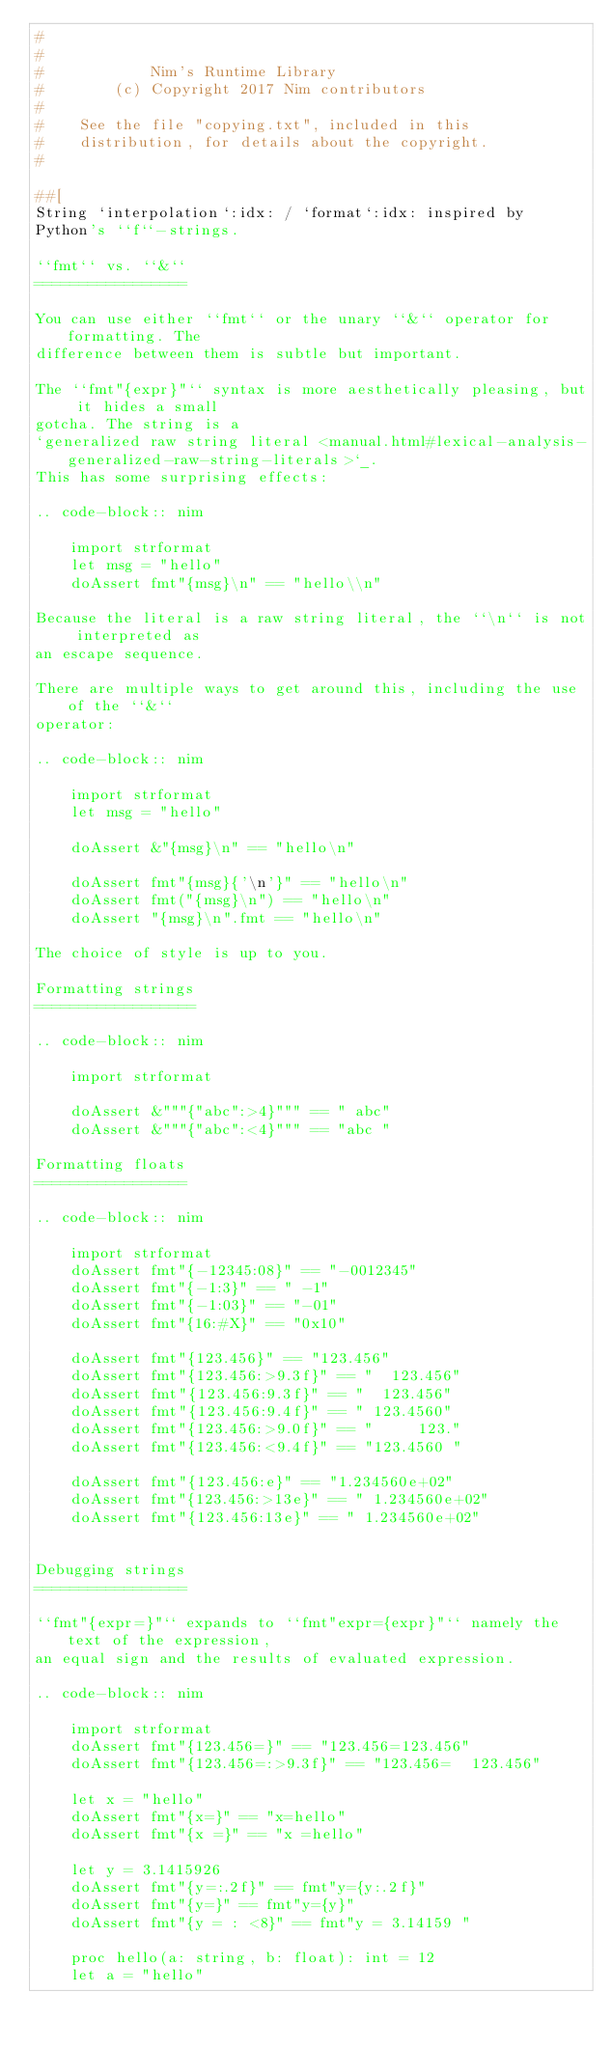Convert code to text. <code><loc_0><loc_0><loc_500><loc_500><_Nim_>#
#
#            Nim's Runtime Library
#        (c) Copyright 2017 Nim contributors
#
#    See the file "copying.txt", included in this
#    distribution, for details about the copyright.
#

##[
String `interpolation`:idx: / `format`:idx: inspired by
Python's ``f``-strings.

``fmt`` vs. ``&``
=================

You can use either ``fmt`` or the unary ``&`` operator for formatting. The
difference between them is subtle but important.

The ``fmt"{expr}"`` syntax is more aesthetically pleasing, but it hides a small
gotcha. The string is a
`generalized raw string literal <manual.html#lexical-analysis-generalized-raw-string-literals>`_.
This has some surprising effects:

.. code-block:: nim

    import strformat
    let msg = "hello"
    doAssert fmt"{msg}\n" == "hello\\n"

Because the literal is a raw string literal, the ``\n`` is not interpreted as
an escape sequence.

There are multiple ways to get around this, including the use of the ``&``
operator:

.. code-block:: nim

    import strformat
    let msg = "hello"

    doAssert &"{msg}\n" == "hello\n"

    doAssert fmt"{msg}{'\n'}" == "hello\n"
    doAssert fmt("{msg}\n") == "hello\n"
    doAssert "{msg}\n".fmt == "hello\n"

The choice of style is up to you.

Formatting strings
==================

.. code-block:: nim

    import strformat

    doAssert &"""{"abc":>4}""" == " abc"
    doAssert &"""{"abc":<4}""" == "abc "

Formatting floats
=================

.. code-block:: nim

    import strformat
    doAssert fmt"{-12345:08}" == "-0012345"
    doAssert fmt"{-1:3}" == " -1"
    doAssert fmt"{-1:03}" == "-01"
    doAssert fmt"{16:#X}" == "0x10"

    doAssert fmt"{123.456}" == "123.456"
    doAssert fmt"{123.456:>9.3f}" == "  123.456"
    doAssert fmt"{123.456:9.3f}" == "  123.456"
    doAssert fmt"{123.456:9.4f}" == " 123.4560"
    doAssert fmt"{123.456:>9.0f}" == "     123."
    doAssert fmt"{123.456:<9.4f}" == "123.4560 "

    doAssert fmt"{123.456:e}" == "1.234560e+02"
    doAssert fmt"{123.456:>13e}" == " 1.234560e+02"
    doAssert fmt"{123.456:13e}" == " 1.234560e+02"


Debugging strings
=================

``fmt"{expr=}"`` expands to ``fmt"expr={expr}"`` namely the text of the expression, 
an equal sign and the results of evaluated expression.

.. code-block:: nim

    import strformat
    doAssert fmt"{123.456=}" == "123.456=123.456"
    doAssert fmt"{123.456=:>9.3f}" == "123.456=  123.456"

    let x = "hello"
    doAssert fmt"{x=}" == "x=hello" 
    doAssert fmt"{x =}" == "x =hello"

    let y = 3.1415926
    doAssert fmt"{y=:.2f}" == fmt"y={y:.2f}"
    doAssert fmt"{y=}" == fmt"y={y}"
    doAssert fmt"{y = : <8}" == fmt"y = 3.14159 "

    proc hello(a: string, b: float): int = 12
    let a = "hello"</code> 